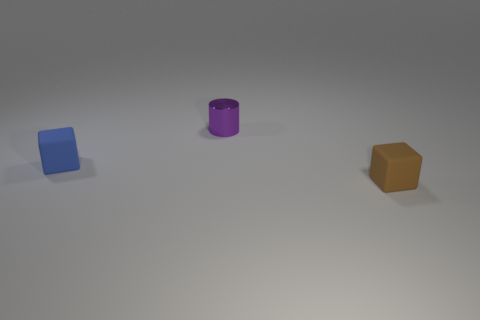Add 3 brown cylinders. How many objects exist? 6 Subtract all cylinders. How many objects are left? 2 Subtract all purple things. Subtract all tiny blue rubber spheres. How many objects are left? 2 Add 2 small brown objects. How many small brown objects are left? 3 Add 1 big brown spheres. How many big brown spheres exist? 1 Subtract 0 brown balls. How many objects are left? 3 